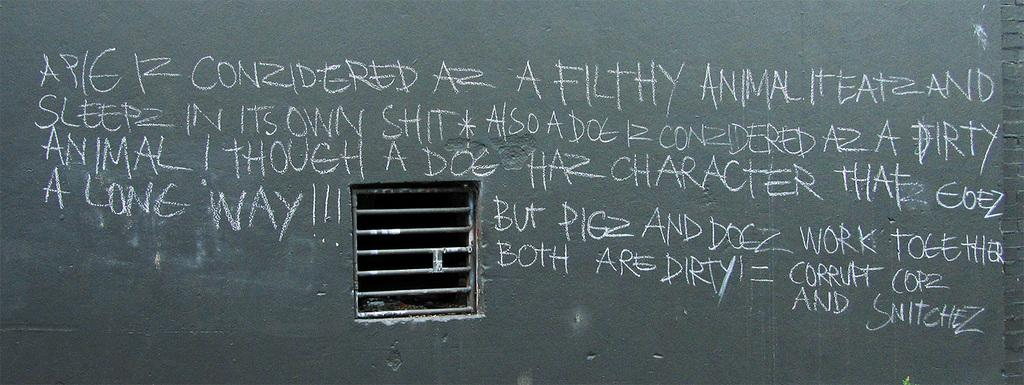What is present on the board in the image? There is writing on the board in the image. What material was used to create the writing on the board? The writing on the board was done with chalk. What can be seen in the background of the image? There is a window in the image. What type of texture can be seen on the wound in the image? There is no wound present in the image; it only features a board with writing on it and a window in the background. Is there any advertisement visible in the image? There is no advertisement present in the image. 